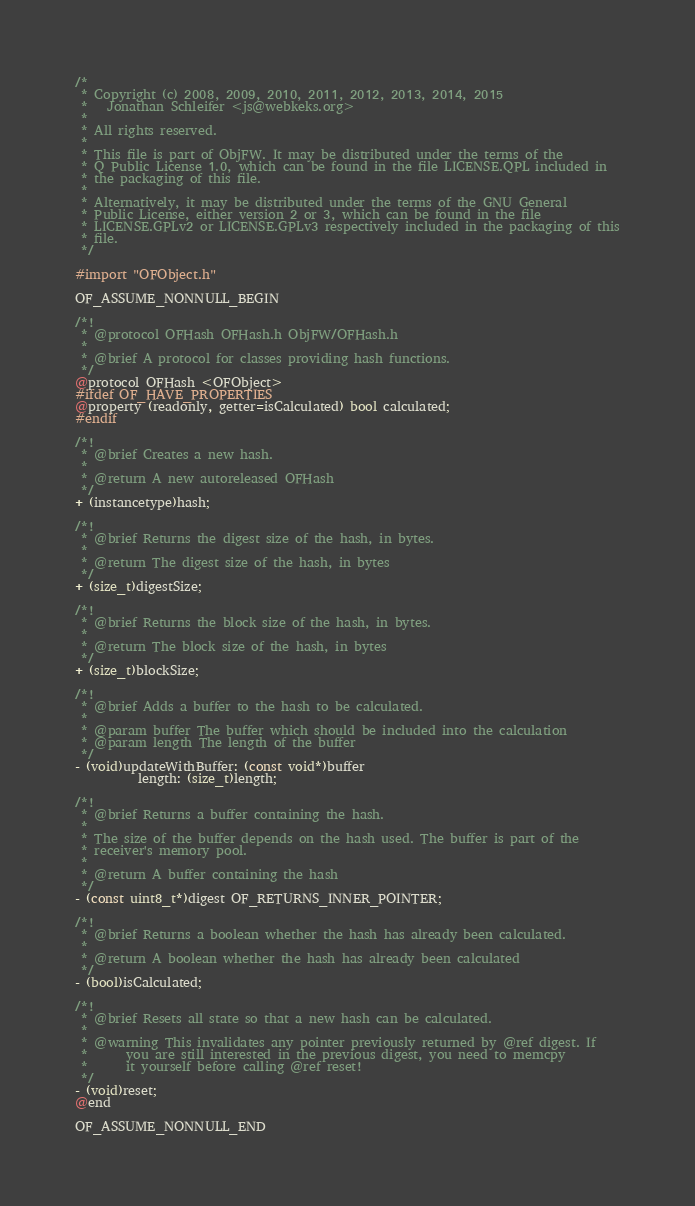<code> <loc_0><loc_0><loc_500><loc_500><_C_>/*
 * Copyright (c) 2008, 2009, 2010, 2011, 2012, 2013, 2014, 2015
 *   Jonathan Schleifer <js@webkeks.org>
 *
 * All rights reserved.
 *
 * This file is part of ObjFW. It may be distributed under the terms of the
 * Q Public License 1.0, which can be found in the file LICENSE.QPL included in
 * the packaging of this file.
 *
 * Alternatively, it may be distributed under the terms of the GNU General
 * Public License, either version 2 or 3, which can be found in the file
 * LICENSE.GPLv2 or LICENSE.GPLv3 respectively included in the packaging of this
 * file.
 */

#import "OFObject.h"

OF_ASSUME_NONNULL_BEGIN

/*!
 * @protocol OFHash OFHash.h ObjFW/OFHash.h
 *
 * @brief A protocol for classes providing hash functions.
 */
@protocol OFHash <OFObject>
#ifdef OF_HAVE_PROPERTIES
@property (readonly, getter=isCalculated) bool calculated;
#endif

/*!
 * @brief Creates a new hash.
 *
 * @return A new autoreleased OFHash
 */
+ (instancetype)hash;

/*!
 * @brief Returns the digest size of the hash, in bytes.
 *
 * @return The digest size of the hash, in bytes
 */
+ (size_t)digestSize;

/*!
 * @brief Returns the block size of the hash, in bytes.
 *
 * @return The block size of the hash, in bytes
 */
+ (size_t)blockSize;

/*!
 * @brief Adds a buffer to the hash to be calculated.
 *
 * @param buffer The buffer which should be included into the calculation
 * @param length The length of the buffer
 */
- (void)updateWithBuffer: (const void*)buffer
		  length: (size_t)length;

/*!
 * @brief Returns a buffer containing the hash.
 *
 * The size of the buffer depends on the hash used. The buffer is part of the
 * receiver's memory pool.
 *
 * @return A buffer containing the hash
 */
- (const uint8_t*)digest OF_RETURNS_INNER_POINTER;

/*!
 * @brief Returns a boolean whether the hash has already been calculated.
 *
 * @return A boolean whether the hash has already been calculated
 */
- (bool)isCalculated;

/*!
 * @brief Resets all state so that a new hash can be calculated.
 *
 * @warning This invalidates any pointer previously returned by @ref digest. If
 *	    you are still interested in the previous digest, you need to memcpy
 *	    it yourself before calling @ref reset!
 */
- (void)reset;
@end

OF_ASSUME_NONNULL_END
</code> 